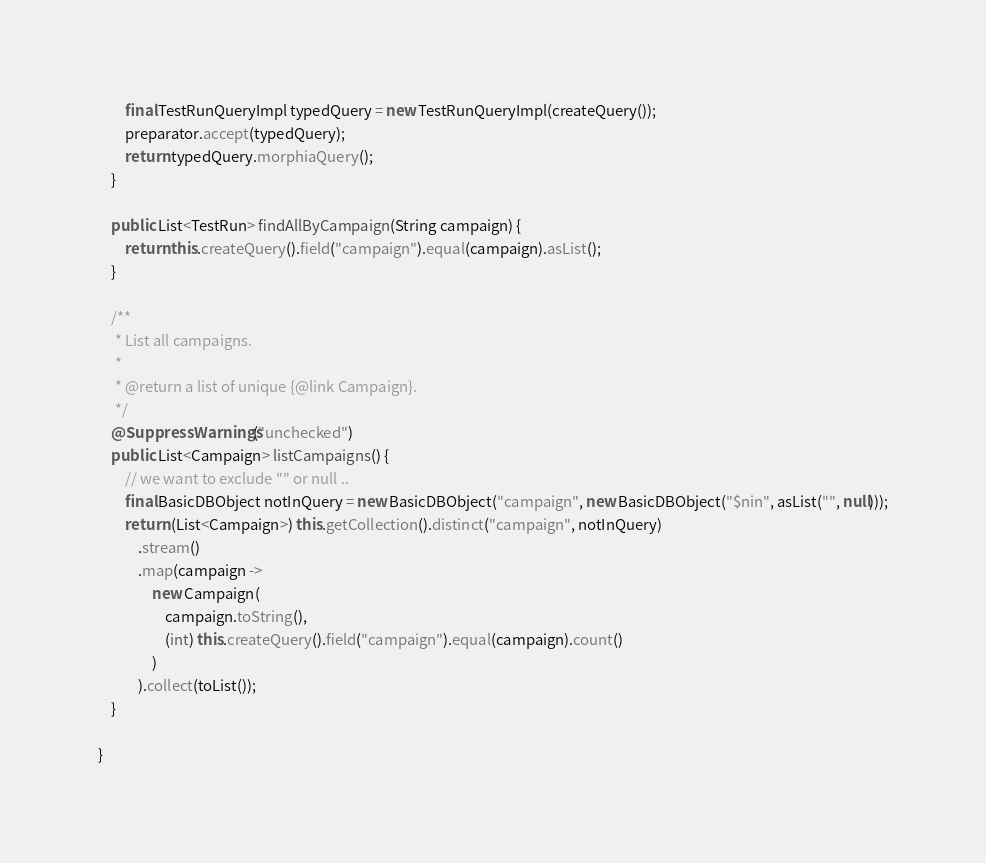<code> <loc_0><loc_0><loc_500><loc_500><_Java_>        final TestRunQueryImpl typedQuery = new TestRunQueryImpl(createQuery());
        preparator.accept(typedQuery);
        return typedQuery.morphiaQuery();
    }

    public List<TestRun> findAllByCampaign(String campaign) {
        return this.createQuery().field("campaign").equal(campaign).asList();
    }

    /**
     * List all campaigns.
     *
     * @return a list of unique {@link Campaign}.
     */
    @SuppressWarnings("unchecked")
    public List<Campaign> listCampaigns() {
        // we want to exclude "" or null ..
        final BasicDBObject notInQuery = new BasicDBObject("campaign", new BasicDBObject("$nin", asList("", null)));
        return (List<Campaign>) this.getCollection().distinct("campaign", notInQuery)
            .stream()
            .map(campaign ->
                new Campaign(
                    campaign.toString(),
                    (int) this.createQuery().field("campaign").equal(campaign).count()
                )
            ).collect(toList());
    }

}
</code> 